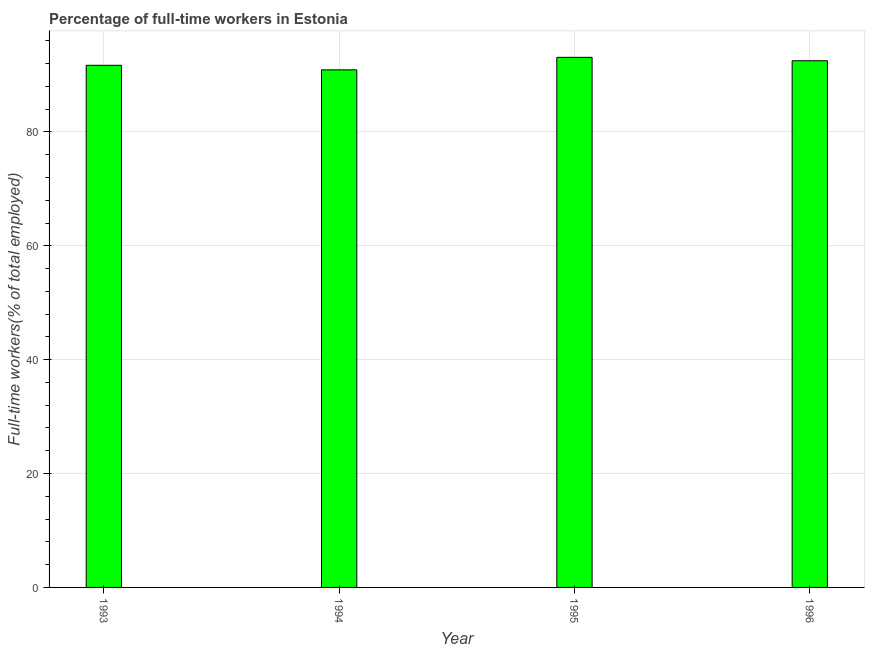Does the graph contain any zero values?
Your answer should be very brief. No. Does the graph contain grids?
Your response must be concise. Yes. What is the title of the graph?
Give a very brief answer. Percentage of full-time workers in Estonia. What is the label or title of the X-axis?
Your answer should be compact. Year. What is the label or title of the Y-axis?
Your response must be concise. Full-time workers(% of total employed). What is the percentage of full-time workers in 1994?
Keep it short and to the point. 90.9. Across all years, what is the maximum percentage of full-time workers?
Your answer should be compact. 93.1. Across all years, what is the minimum percentage of full-time workers?
Keep it short and to the point. 90.9. In which year was the percentage of full-time workers maximum?
Give a very brief answer. 1995. In which year was the percentage of full-time workers minimum?
Provide a succinct answer. 1994. What is the sum of the percentage of full-time workers?
Make the answer very short. 368.2. What is the difference between the percentage of full-time workers in 1993 and 1996?
Provide a short and direct response. -0.8. What is the average percentage of full-time workers per year?
Offer a terse response. 92.05. What is the median percentage of full-time workers?
Your response must be concise. 92.1. In how many years, is the percentage of full-time workers greater than 16 %?
Ensure brevity in your answer.  4. Do a majority of the years between 1995 and 1994 (inclusive) have percentage of full-time workers greater than 40 %?
Give a very brief answer. No. What is the ratio of the percentage of full-time workers in 1994 to that in 1995?
Your answer should be compact. 0.98. What is the difference between the highest and the lowest percentage of full-time workers?
Provide a short and direct response. 2.2. How many bars are there?
Offer a terse response. 4. Are all the bars in the graph horizontal?
Make the answer very short. No. Are the values on the major ticks of Y-axis written in scientific E-notation?
Offer a terse response. No. What is the Full-time workers(% of total employed) of 1993?
Your response must be concise. 91.7. What is the Full-time workers(% of total employed) in 1994?
Provide a short and direct response. 90.9. What is the Full-time workers(% of total employed) in 1995?
Give a very brief answer. 93.1. What is the Full-time workers(% of total employed) in 1996?
Ensure brevity in your answer.  92.5. What is the difference between the Full-time workers(% of total employed) in 1993 and 1994?
Your answer should be compact. 0.8. What is the difference between the Full-time workers(% of total employed) in 1993 and 1995?
Provide a succinct answer. -1.4. What is the difference between the Full-time workers(% of total employed) in 1994 and 1996?
Offer a terse response. -1.6. What is the ratio of the Full-time workers(% of total employed) in 1993 to that in 1995?
Your answer should be compact. 0.98. What is the ratio of the Full-time workers(% of total employed) in 1993 to that in 1996?
Provide a short and direct response. 0.99. What is the ratio of the Full-time workers(% of total employed) in 1994 to that in 1995?
Provide a succinct answer. 0.98. What is the ratio of the Full-time workers(% of total employed) in 1994 to that in 1996?
Offer a terse response. 0.98. 